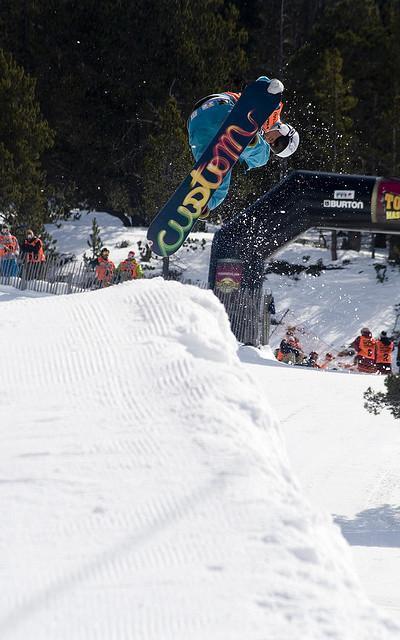How many of the train cars can you see someone sticking their head out of?
Give a very brief answer. 0. 